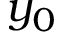<formula> <loc_0><loc_0><loc_500><loc_500>y _ { 0 }</formula> 